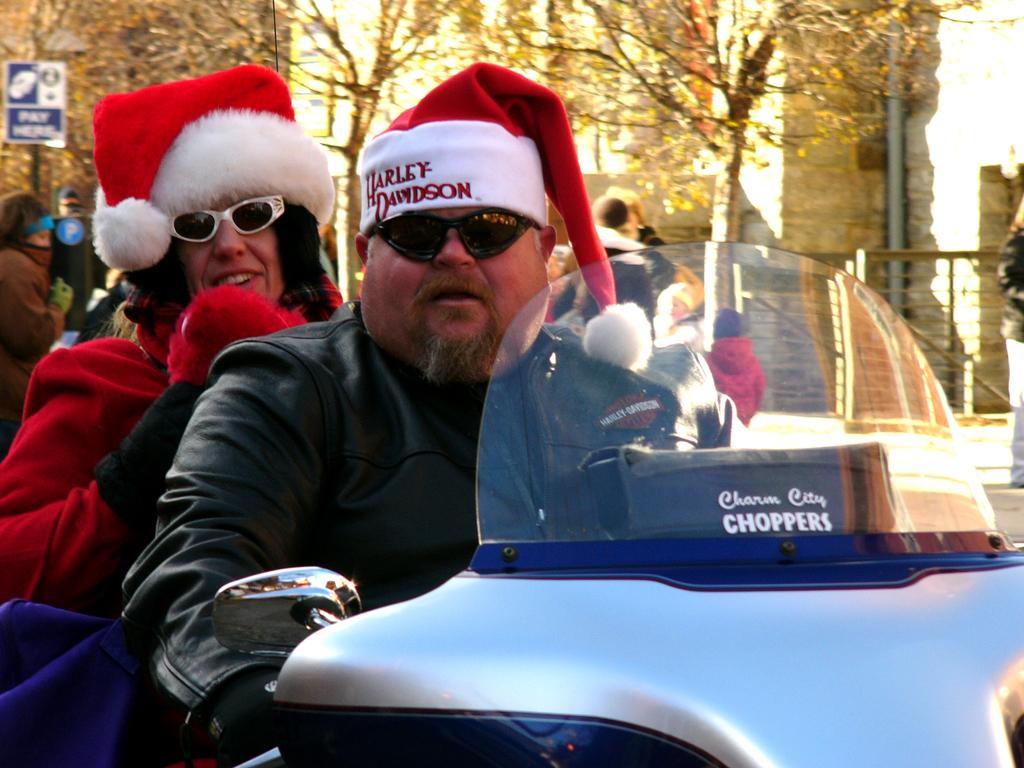In one or two sentences, can you explain what this image depicts? In this picture we can see a man and a woman sitting on a vehicle. We can see few people at the back. There is a signboard on the pole. We can see few trees in the background. 